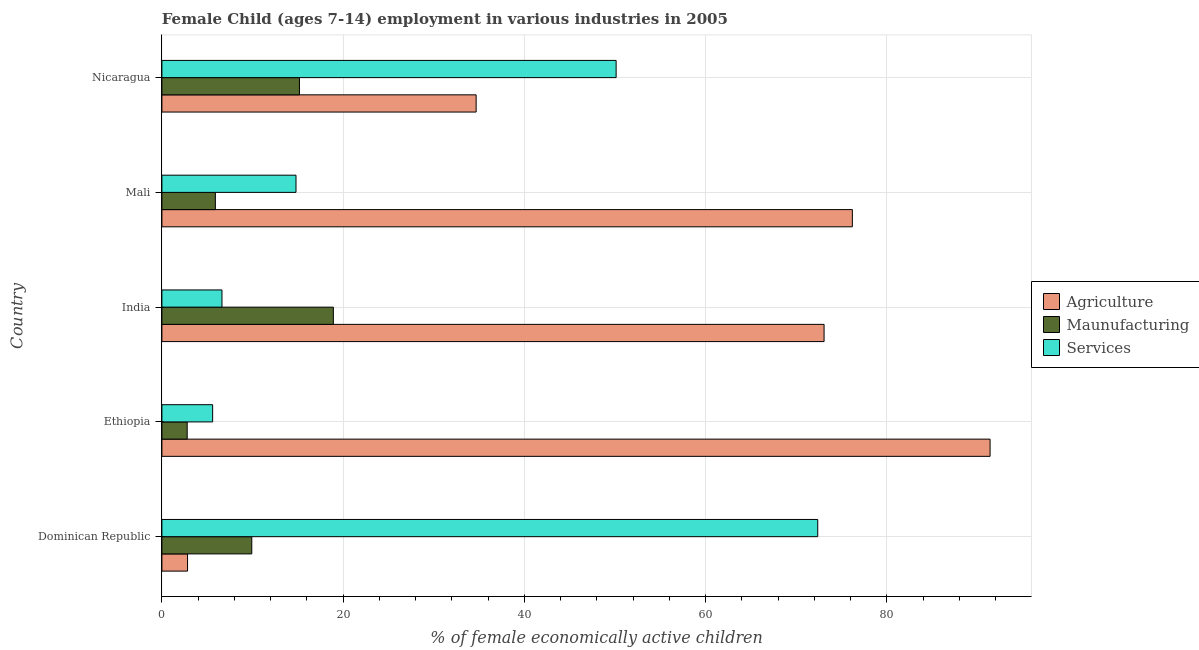Are the number of bars on each tick of the Y-axis equal?
Your answer should be compact. Yes. How many bars are there on the 5th tick from the bottom?
Keep it short and to the point. 3. What is the label of the 1st group of bars from the top?
Provide a short and direct response. Nicaragua. In how many cases, is the number of bars for a given country not equal to the number of legend labels?
Keep it short and to the point. 0. What is the percentage of economically active children in services in Nicaragua?
Ensure brevity in your answer.  50.13. Across all countries, what is the maximum percentage of economically active children in manufacturing?
Provide a succinct answer. 18.92. Across all countries, what is the minimum percentage of economically active children in manufacturing?
Keep it short and to the point. 2.79. In which country was the percentage of economically active children in services maximum?
Keep it short and to the point. Dominican Republic. In which country was the percentage of economically active children in agriculture minimum?
Provide a succinct answer. Dominican Republic. What is the total percentage of economically active children in agriculture in the graph?
Your answer should be very brief. 278.19. What is the difference between the percentage of economically active children in agriculture in Dominican Republic and that in Mali?
Make the answer very short. -73.37. What is the difference between the percentage of economically active children in manufacturing in Ethiopia and the percentage of economically active children in services in India?
Offer a very short reply. -3.84. What is the average percentage of economically active children in services per country?
Your answer should be compact. 29.91. What is the difference between the percentage of economically active children in manufacturing and percentage of economically active children in agriculture in India?
Provide a short and direct response. -54.16. In how many countries, is the percentage of economically active children in manufacturing greater than 8 %?
Make the answer very short. 3. What is the ratio of the percentage of economically active children in manufacturing in Ethiopia to that in India?
Make the answer very short. 0.15. Is the difference between the percentage of economically active children in manufacturing in Dominican Republic and Ethiopia greater than the difference between the percentage of economically active children in services in Dominican Republic and Ethiopia?
Offer a terse response. No. What is the difference between the highest and the second highest percentage of economically active children in services?
Your response must be concise. 22.25. What is the difference between the highest and the lowest percentage of economically active children in services?
Your response must be concise. 66.78. In how many countries, is the percentage of economically active children in manufacturing greater than the average percentage of economically active children in manufacturing taken over all countries?
Make the answer very short. 2. Is the sum of the percentage of economically active children in manufacturing in India and Mali greater than the maximum percentage of economically active children in agriculture across all countries?
Provide a succinct answer. No. What does the 1st bar from the top in Nicaragua represents?
Give a very brief answer. Services. What does the 3rd bar from the bottom in Ethiopia represents?
Keep it short and to the point. Services. How many bars are there?
Offer a terse response. 15. How many countries are there in the graph?
Your answer should be very brief. 5. What is the difference between two consecutive major ticks on the X-axis?
Provide a succinct answer. 20. Does the graph contain any zero values?
Your response must be concise. No. Does the graph contain grids?
Give a very brief answer. Yes. Where does the legend appear in the graph?
Your answer should be compact. Center right. How many legend labels are there?
Offer a very short reply. 3. How are the legend labels stacked?
Your response must be concise. Vertical. What is the title of the graph?
Offer a terse response. Female Child (ages 7-14) employment in various industries in 2005. What is the label or title of the X-axis?
Give a very brief answer. % of female economically active children. What is the % of female economically active children in Agriculture in Dominican Republic?
Your answer should be compact. 2.83. What is the % of female economically active children of Maunufacturing in Dominican Republic?
Give a very brief answer. 9.92. What is the % of female economically active children in Services in Dominican Republic?
Provide a succinct answer. 72.38. What is the % of female economically active children of Agriculture in Ethiopia?
Provide a succinct answer. 91.4. What is the % of female economically active children in Maunufacturing in Ethiopia?
Your response must be concise. 2.79. What is the % of female economically active children in Agriculture in India?
Give a very brief answer. 73.08. What is the % of female economically active children of Maunufacturing in India?
Offer a terse response. 18.92. What is the % of female economically active children of Services in India?
Give a very brief answer. 6.63. What is the % of female economically active children in Agriculture in Mali?
Provide a succinct answer. 76.2. What is the % of female economically active children of Maunufacturing in Mali?
Your response must be concise. 5.9. What is the % of female economically active children in Agriculture in Nicaragua?
Provide a short and direct response. 34.68. What is the % of female economically active children of Maunufacturing in Nicaragua?
Your answer should be compact. 15.18. What is the % of female economically active children of Services in Nicaragua?
Offer a terse response. 50.13. Across all countries, what is the maximum % of female economically active children of Agriculture?
Offer a very short reply. 91.4. Across all countries, what is the maximum % of female economically active children in Maunufacturing?
Keep it short and to the point. 18.92. Across all countries, what is the maximum % of female economically active children in Services?
Ensure brevity in your answer.  72.38. Across all countries, what is the minimum % of female economically active children in Agriculture?
Offer a very short reply. 2.83. Across all countries, what is the minimum % of female economically active children in Maunufacturing?
Make the answer very short. 2.79. What is the total % of female economically active children of Agriculture in the graph?
Offer a terse response. 278.19. What is the total % of female economically active children in Maunufacturing in the graph?
Offer a terse response. 52.71. What is the total % of female economically active children in Services in the graph?
Offer a terse response. 149.54. What is the difference between the % of female economically active children in Agriculture in Dominican Republic and that in Ethiopia?
Give a very brief answer. -88.57. What is the difference between the % of female economically active children in Maunufacturing in Dominican Republic and that in Ethiopia?
Offer a terse response. 7.13. What is the difference between the % of female economically active children in Services in Dominican Republic and that in Ethiopia?
Ensure brevity in your answer.  66.78. What is the difference between the % of female economically active children of Agriculture in Dominican Republic and that in India?
Your answer should be very brief. -70.25. What is the difference between the % of female economically active children in Services in Dominican Republic and that in India?
Your answer should be very brief. 65.75. What is the difference between the % of female economically active children in Agriculture in Dominican Republic and that in Mali?
Offer a very short reply. -73.37. What is the difference between the % of female economically active children of Maunufacturing in Dominican Republic and that in Mali?
Offer a very short reply. 4.02. What is the difference between the % of female economically active children in Services in Dominican Republic and that in Mali?
Make the answer very short. 57.58. What is the difference between the % of female economically active children in Agriculture in Dominican Republic and that in Nicaragua?
Make the answer very short. -31.85. What is the difference between the % of female economically active children of Maunufacturing in Dominican Republic and that in Nicaragua?
Your answer should be very brief. -5.26. What is the difference between the % of female economically active children of Services in Dominican Republic and that in Nicaragua?
Your answer should be compact. 22.25. What is the difference between the % of female economically active children of Agriculture in Ethiopia and that in India?
Make the answer very short. 18.32. What is the difference between the % of female economically active children of Maunufacturing in Ethiopia and that in India?
Provide a succinct answer. -16.13. What is the difference between the % of female economically active children of Services in Ethiopia and that in India?
Your answer should be very brief. -1.03. What is the difference between the % of female economically active children of Agriculture in Ethiopia and that in Mali?
Offer a terse response. 15.2. What is the difference between the % of female economically active children of Maunufacturing in Ethiopia and that in Mali?
Keep it short and to the point. -3.11. What is the difference between the % of female economically active children in Services in Ethiopia and that in Mali?
Keep it short and to the point. -9.2. What is the difference between the % of female economically active children in Agriculture in Ethiopia and that in Nicaragua?
Your response must be concise. 56.72. What is the difference between the % of female economically active children of Maunufacturing in Ethiopia and that in Nicaragua?
Give a very brief answer. -12.39. What is the difference between the % of female economically active children of Services in Ethiopia and that in Nicaragua?
Make the answer very short. -44.53. What is the difference between the % of female economically active children in Agriculture in India and that in Mali?
Offer a very short reply. -3.12. What is the difference between the % of female economically active children in Maunufacturing in India and that in Mali?
Provide a succinct answer. 13.02. What is the difference between the % of female economically active children in Services in India and that in Mali?
Offer a terse response. -8.17. What is the difference between the % of female economically active children in Agriculture in India and that in Nicaragua?
Make the answer very short. 38.4. What is the difference between the % of female economically active children of Maunufacturing in India and that in Nicaragua?
Ensure brevity in your answer.  3.74. What is the difference between the % of female economically active children of Services in India and that in Nicaragua?
Make the answer very short. -43.5. What is the difference between the % of female economically active children of Agriculture in Mali and that in Nicaragua?
Ensure brevity in your answer.  41.52. What is the difference between the % of female economically active children in Maunufacturing in Mali and that in Nicaragua?
Provide a short and direct response. -9.28. What is the difference between the % of female economically active children in Services in Mali and that in Nicaragua?
Your answer should be very brief. -35.33. What is the difference between the % of female economically active children of Agriculture in Dominican Republic and the % of female economically active children of Maunufacturing in Ethiopia?
Your response must be concise. 0.04. What is the difference between the % of female economically active children of Agriculture in Dominican Republic and the % of female economically active children of Services in Ethiopia?
Give a very brief answer. -2.77. What is the difference between the % of female economically active children in Maunufacturing in Dominican Republic and the % of female economically active children in Services in Ethiopia?
Ensure brevity in your answer.  4.32. What is the difference between the % of female economically active children of Agriculture in Dominican Republic and the % of female economically active children of Maunufacturing in India?
Provide a succinct answer. -16.09. What is the difference between the % of female economically active children in Maunufacturing in Dominican Republic and the % of female economically active children in Services in India?
Make the answer very short. 3.29. What is the difference between the % of female economically active children in Agriculture in Dominican Republic and the % of female economically active children in Maunufacturing in Mali?
Ensure brevity in your answer.  -3.07. What is the difference between the % of female economically active children in Agriculture in Dominican Republic and the % of female economically active children in Services in Mali?
Offer a very short reply. -11.97. What is the difference between the % of female economically active children in Maunufacturing in Dominican Republic and the % of female economically active children in Services in Mali?
Provide a short and direct response. -4.88. What is the difference between the % of female economically active children in Agriculture in Dominican Republic and the % of female economically active children in Maunufacturing in Nicaragua?
Ensure brevity in your answer.  -12.35. What is the difference between the % of female economically active children in Agriculture in Dominican Republic and the % of female economically active children in Services in Nicaragua?
Give a very brief answer. -47.3. What is the difference between the % of female economically active children in Maunufacturing in Dominican Republic and the % of female economically active children in Services in Nicaragua?
Offer a terse response. -40.21. What is the difference between the % of female economically active children of Agriculture in Ethiopia and the % of female economically active children of Maunufacturing in India?
Offer a very short reply. 72.48. What is the difference between the % of female economically active children of Agriculture in Ethiopia and the % of female economically active children of Services in India?
Ensure brevity in your answer.  84.77. What is the difference between the % of female economically active children in Maunufacturing in Ethiopia and the % of female economically active children in Services in India?
Offer a very short reply. -3.84. What is the difference between the % of female economically active children in Agriculture in Ethiopia and the % of female economically active children in Maunufacturing in Mali?
Your answer should be very brief. 85.5. What is the difference between the % of female economically active children of Agriculture in Ethiopia and the % of female economically active children of Services in Mali?
Give a very brief answer. 76.6. What is the difference between the % of female economically active children of Maunufacturing in Ethiopia and the % of female economically active children of Services in Mali?
Give a very brief answer. -12.01. What is the difference between the % of female economically active children of Agriculture in Ethiopia and the % of female economically active children of Maunufacturing in Nicaragua?
Provide a short and direct response. 76.22. What is the difference between the % of female economically active children of Agriculture in Ethiopia and the % of female economically active children of Services in Nicaragua?
Your response must be concise. 41.27. What is the difference between the % of female economically active children in Maunufacturing in Ethiopia and the % of female economically active children in Services in Nicaragua?
Your answer should be very brief. -47.34. What is the difference between the % of female economically active children in Agriculture in India and the % of female economically active children in Maunufacturing in Mali?
Make the answer very short. 67.18. What is the difference between the % of female economically active children in Agriculture in India and the % of female economically active children in Services in Mali?
Your response must be concise. 58.28. What is the difference between the % of female economically active children in Maunufacturing in India and the % of female economically active children in Services in Mali?
Provide a short and direct response. 4.12. What is the difference between the % of female economically active children in Agriculture in India and the % of female economically active children in Maunufacturing in Nicaragua?
Your answer should be very brief. 57.9. What is the difference between the % of female economically active children in Agriculture in India and the % of female economically active children in Services in Nicaragua?
Provide a succinct answer. 22.95. What is the difference between the % of female economically active children of Maunufacturing in India and the % of female economically active children of Services in Nicaragua?
Your answer should be very brief. -31.21. What is the difference between the % of female economically active children in Agriculture in Mali and the % of female economically active children in Maunufacturing in Nicaragua?
Your response must be concise. 61.02. What is the difference between the % of female economically active children in Agriculture in Mali and the % of female economically active children in Services in Nicaragua?
Your response must be concise. 26.07. What is the difference between the % of female economically active children of Maunufacturing in Mali and the % of female economically active children of Services in Nicaragua?
Your answer should be very brief. -44.23. What is the average % of female economically active children of Agriculture per country?
Provide a succinct answer. 55.64. What is the average % of female economically active children in Maunufacturing per country?
Offer a terse response. 10.54. What is the average % of female economically active children in Services per country?
Make the answer very short. 29.91. What is the difference between the % of female economically active children of Agriculture and % of female economically active children of Maunufacturing in Dominican Republic?
Provide a short and direct response. -7.09. What is the difference between the % of female economically active children in Agriculture and % of female economically active children in Services in Dominican Republic?
Provide a short and direct response. -69.55. What is the difference between the % of female economically active children in Maunufacturing and % of female economically active children in Services in Dominican Republic?
Your response must be concise. -62.46. What is the difference between the % of female economically active children in Agriculture and % of female economically active children in Maunufacturing in Ethiopia?
Give a very brief answer. 88.61. What is the difference between the % of female economically active children of Agriculture and % of female economically active children of Services in Ethiopia?
Your answer should be very brief. 85.8. What is the difference between the % of female economically active children in Maunufacturing and % of female economically active children in Services in Ethiopia?
Offer a terse response. -2.81. What is the difference between the % of female economically active children of Agriculture and % of female economically active children of Maunufacturing in India?
Keep it short and to the point. 54.16. What is the difference between the % of female economically active children in Agriculture and % of female economically active children in Services in India?
Your answer should be compact. 66.45. What is the difference between the % of female economically active children in Maunufacturing and % of female economically active children in Services in India?
Offer a terse response. 12.29. What is the difference between the % of female economically active children in Agriculture and % of female economically active children in Maunufacturing in Mali?
Your answer should be compact. 70.3. What is the difference between the % of female economically active children of Agriculture and % of female economically active children of Services in Mali?
Give a very brief answer. 61.4. What is the difference between the % of female economically active children of Maunufacturing and % of female economically active children of Services in Mali?
Provide a succinct answer. -8.9. What is the difference between the % of female economically active children of Agriculture and % of female economically active children of Maunufacturing in Nicaragua?
Your answer should be very brief. 19.5. What is the difference between the % of female economically active children of Agriculture and % of female economically active children of Services in Nicaragua?
Your response must be concise. -15.45. What is the difference between the % of female economically active children in Maunufacturing and % of female economically active children in Services in Nicaragua?
Give a very brief answer. -34.95. What is the ratio of the % of female economically active children in Agriculture in Dominican Republic to that in Ethiopia?
Offer a terse response. 0.03. What is the ratio of the % of female economically active children of Maunufacturing in Dominican Republic to that in Ethiopia?
Your answer should be compact. 3.56. What is the ratio of the % of female economically active children in Services in Dominican Republic to that in Ethiopia?
Keep it short and to the point. 12.93. What is the ratio of the % of female economically active children in Agriculture in Dominican Republic to that in India?
Keep it short and to the point. 0.04. What is the ratio of the % of female economically active children of Maunufacturing in Dominican Republic to that in India?
Keep it short and to the point. 0.52. What is the ratio of the % of female economically active children of Services in Dominican Republic to that in India?
Ensure brevity in your answer.  10.92. What is the ratio of the % of female economically active children of Agriculture in Dominican Republic to that in Mali?
Keep it short and to the point. 0.04. What is the ratio of the % of female economically active children in Maunufacturing in Dominican Republic to that in Mali?
Provide a short and direct response. 1.68. What is the ratio of the % of female economically active children of Services in Dominican Republic to that in Mali?
Your answer should be compact. 4.89. What is the ratio of the % of female economically active children of Agriculture in Dominican Republic to that in Nicaragua?
Your response must be concise. 0.08. What is the ratio of the % of female economically active children of Maunufacturing in Dominican Republic to that in Nicaragua?
Keep it short and to the point. 0.65. What is the ratio of the % of female economically active children of Services in Dominican Republic to that in Nicaragua?
Ensure brevity in your answer.  1.44. What is the ratio of the % of female economically active children in Agriculture in Ethiopia to that in India?
Your answer should be very brief. 1.25. What is the ratio of the % of female economically active children of Maunufacturing in Ethiopia to that in India?
Make the answer very short. 0.15. What is the ratio of the % of female economically active children in Services in Ethiopia to that in India?
Make the answer very short. 0.84. What is the ratio of the % of female economically active children of Agriculture in Ethiopia to that in Mali?
Provide a succinct answer. 1.2. What is the ratio of the % of female economically active children of Maunufacturing in Ethiopia to that in Mali?
Offer a very short reply. 0.47. What is the ratio of the % of female economically active children of Services in Ethiopia to that in Mali?
Offer a terse response. 0.38. What is the ratio of the % of female economically active children in Agriculture in Ethiopia to that in Nicaragua?
Your answer should be compact. 2.64. What is the ratio of the % of female economically active children in Maunufacturing in Ethiopia to that in Nicaragua?
Your answer should be compact. 0.18. What is the ratio of the % of female economically active children of Services in Ethiopia to that in Nicaragua?
Give a very brief answer. 0.11. What is the ratio of the % of female economically active children in Agriculture in India to that in Mali?
Keep it short and to the point. 0.96. What is the ratio of the % of female economically active children of Maunufacturing in India to that in Mali?
Your answer should be compact. 3.21. What is the ratio of the % of female economically active children of Services in India to that in Mali?
Provide a succinct answer. 0.45. What is the ratio of the % of female economically active children of Agriculture in India to that in Nicaragua?
Provide a succinct answer. 2.11. What is the ratio of the % of female economically active children of Maunufacturing in India to that in Nicaragua?
Your response must be concise. 1.25. What is the ratio of the % of female economically active children in Services in India to that in Nicaragua?
Make the answer very short. 0.13. What is the ratio of the % of female economically active children of Agriculture in Mali to that in Nicaragua?
Ensure brevity in your answer.  2.2. What is the ratio of the % of female economically active children in Maunufacturing in Mali to that in Nicaragua?
Your response must be concise. 0.39. What is the ratio of the % of female economically active children of Services in Mali to that in Nicaragua?
Your answer should be very brief. 0.3. What is the difference between the highest and the second highest % of female economically active children in Maunufacturing?
Offer a very short reply. 3.74. What is the difference between the highest and the second highest % of female economically active children of Services?
Make the answer very short. 22.25. What is the difference between the highest and the lowest % of female economically active children in Agriculture?
Provide a succinct answer. 88.57. What is the difference between the highest and the lowest % of female economically active children of Maunufacturing?
Ensure brevity in your answer.  16.13. What is the difference between the highest and the lowest % of female economically active children of Services?
Your response must be concise. 66.78. 